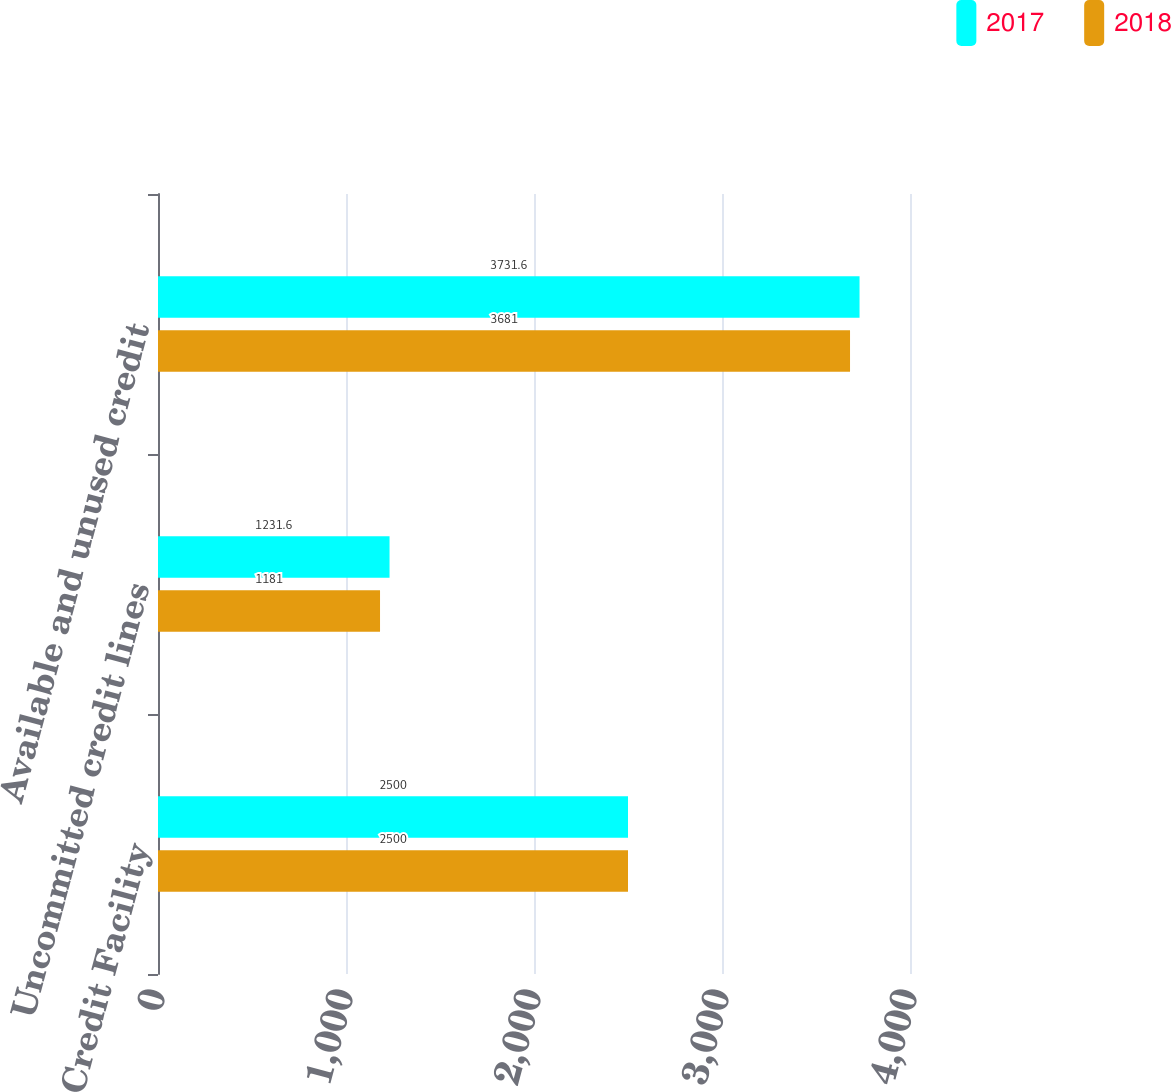Convert chart. <chart><loc_0><loc_0><loc_500><loc_500><stacked_bar_chart><ecel><fcel>Credit Facility<fcel>Uncommitted credit lines<fcel>Available and unused credit<nl><fcel>2017<fcel>2500<fcel>1231.6<fcel>3731.6<nl><fcel>2018<fcel>2500<fcel>1181<fcel>3681<nl></chart> 